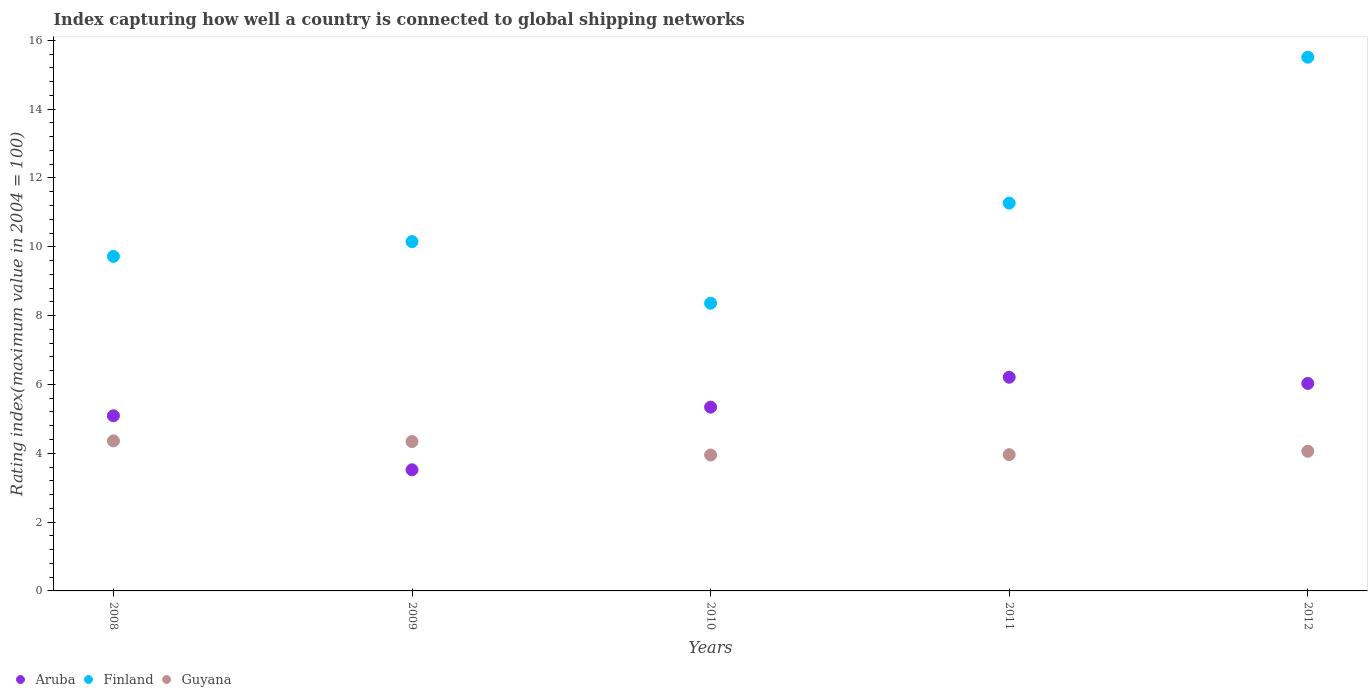How many different coloured dotlines are there?
Make the answer very short. 3. What is the rating index in Aruba in 2008?
Give a very brief answer. 5.09. Across all years, what is the maximum rating index in Aruba?
Ensure brevity in your answer.  6.21. Across all years, what is the minimum rating index in Finland?
Provide a succinct answer. 8.36. In which year was the rating index in Aruba maximum?
Keep it short and to the point. 2011. In which year was the rating index in Finland minimum?
Make the answer very short. 2010. What is the total rating index in Guyana in the graph?
Your answer should be compact. 20.67. What is the difference between the rating index in Aruba in 2009 and that in 2012?
Your answer should be very brief. -2.51. What is the difference between the rating index in Guyana in 2012 and the rating index in Finland in 2009?
Offer a very short reply. -6.09. What is the average rating index in Aruba per year?
Ensure brevity in your answer.  5.24. In the year 2010, what is the difference between the rating index in Guyana and rating index in Finland?
Your answer should be compact. -4.41. In how many years, is the rating index in Guyana greater than 6.8?
Your answer should be very brief. 0. What is the ratio of the rating index in Finland in 2011 to that in 2012?
Give a very brief answer. 0.73. Is the rating index in Guyana in 2011 less than that in 2012?
Provide a succinct answer. Yes. Is the difference between the rating index in Guyana in 2008 and 2011 greater than the difference between the rating index in Finland in 2008 and 2011?
Make the answer very short. Yes. What is the difference between the highest and the second highest rating index in Aruba?
Give a very brief answer. 0.18. What is the difference between the highest and the lowest rating index in Aruba?
Offer a very short reply. 2.69. In how many years, is the rating index in Aruba greater than the average rating index in Aruba taken over all years?
Your answer should be compact. 3. Is the sum of the rating index in Guyana in 2010 and 2011 greater than the maximum rating index in Aruba across all years?
Ensure brevity in your answer.  Yes. Does the rating index in Finland monotonically increase over the years?
Your response must be concise. No. How many dotlines are there?
Offer a very short reply. 3. What is the difference between two consecutive major ticks on the Y-axis?
Your response must be concise. 2. Are the values on the major ticks of Y-axis written in scientific E-notation?
Give a very brief answer. No. Does the graph contain any zero values?
Offer a terse response. No. Where does the legend appear in the graph?
Keep it short and to the point. Bottom left. How many legend labels are there?
Give a very brief answer. 3. What is the title of the graph?
Offer a very short reply. Index capturing how well a country is connected to global shipping networks. Does "Dominican Republic" appear as one of the legend labels in the graph?
Offer a terse response. No. What is the label or title of the Y-axis?
Make the answer very short. Rating index(maximum value in 2004 = 100). What is the Rating index(maximum value in 2004 = 100) in Aruba in 2008?
Keep it short and to the point. 5.09. What is the Rating index(maximum value in 2004 = 100) in Finland in 2008?
Provide a succinct answer. 9.72. What is the Rating index(maximum value in 2004 = 100) in Guyana in 2008?
Make the answer very short. 4.36. What is the Rating index(maximum value in 2004 = 100) in Aruba in 2009?
Ensure brevity in your answer.  3.52. What is the Rating index(maximum value in 2004 = 100) in Finland in 2009?
Offer a terse response. 10.15. What is the Rating index(maximum value in 2004 = 100) in Guyana in 2009?
Provide a succinct answer. 4.34. What is the Rating index(maximum value in 2004 = 100) of Aruba in 2010?
Your response must be concise. 5.34. What is the Rating index(maximum value in 2004 = 100) of Finland in 2010?
Offer a very short reply. 8.36. What is the Rating index(maximum value in 2004 = 100) in Guyana in 2010?
Your answer should be very brief. 3.95. What is the Rating index(maximum value in 2004 = 100) in Aruba in 2011?
Offer a terse response. 6.21. What is the Rating index(maximum value in 2004 = 100) in Finland in 2011?
Offer a terse response. 11.27. What is the Rating index(maximum value in 2004 = 100) of Guyana in 2011?
Offer a terse response. 3.96. What is the Rating index(maximum value in 2004 = 100) of Aruba in 2012?
Your response must be concise. 6.03. What is the Rating index(maximum value in 2004 = 100) in Finland in 2012?
Offer a terse response. 15.51. What is the Rating index(maximum value in 2004 = 100) of Guyana in 2012?
Make the answer very short. 4.06. Across all years, what is the maximum Rating index(maximum value in 2004 = 100) of Aruba?
Your answer should be very brief. 6.21. Across all years, what is the maximum Rating index(maximum value in 2004 = 100) in Finland?
Make the answer very short. 15.51. Across all years, what is the maximum Rating index(maximum value in 2004 = 100) of Guyana?
Your response must be concise. 4.36. Across all years, what is the minimum Rating index(maximum value in 2004 = 100) of Aruba?
Your answer should be very brief. 3.52. Across all years, what is the minimum Rating index(maximum value in 2004 = 100) in Finland?
Your answer should be very brief. 8.36. Across all years, what is the minimum Rating index(maximum value in 2004 = 100) in Guyana?
Ensure brevity in your answer.  3.95. What is the total Rating index(maximum value in 2004 = 100) of Aruba in the graph?
Ensure brevity in your answer.  26.19. What is the total Rating index(maximum value in 2004 = 100) in Finland in the graph?
Your response must be concise. 55.01. What is the total Rating index(maximum value in 2004 = 100) of Guyana in the graph?
Your answer should be compact. 20.67. What is the difference between the Rating index(maximum value in 2004 = 100) of Aruba in 2008 and that in 2009?
Provide a short and direct response. 1.57. What is the difference between the Rating index(maximum value in 2004 = 100) in Finland in 2008 and that in 2009?
Provide a succinct answer. -0.43. What is the difference between the Rating index(maximum value in 2004 = 100) in Guyana in 2008 and that in 2009?
Give a very brief answer. 0.02. What is the difference between the Rating index(maximum value in 2004 = 100) in Finland in 2008 and that in 2010?
Make the answer very short. 1.36. What is the difference between the Rating index(maximum value in 2004 = 100) of Guyana in 2008 and that in 2010?
Your response must be concise. 0.41. What is the difference between the Rating index(maximum value in 2004 = 100) in Aruba in 2008 and that in 2011?
Give a very brief answer. -1.12. What is the difference between the Rating index(maximum value in 2004 = 100) in Finland in 2008 and that in 2011?
Your response must be concise. -1.55. What is the difference between the Rating index(maximum value in 2004 = 100) in Aruba in 2008 and that in 2012?
Your answer should be very brief. -0.94. What is the difference between the Rating index(maximum value in 2004 = 100) of Finland in 2008 and that in 2012?
Your answer should be compact. -5.79. What is the difference between the Rating index(maximum value in 2004 = 100) of Guyana in 2008 and that in 2012?
Your answer should be very brief. 0.3. What is the difference between the Rating index(maximum value in 2004 = 100) of Aruba in 2009 and that in 2010?
Ensure brevity in your answer.  -1.82. What is the difference between the Rating index(maximum value in 2004 = 100) in Finland in 2009 and that in 2010?
Make the answer very short. 1.79. What is the difference between the Rating index(maximum value in 2004 = 100) in Guyana in 2009 and that in 2010?
Keep it short and to the point. 0.39. What is the difference between the Rating index(maximum value in 2004 = 100) in Aruba in 2009 and that in 2011?
Make the answer very short. -2.69. What is the difference between the Rating index(maximum value in 2004 = 100) of Finland in 2009 and that in 2011?
Provide a succinct answer. -1.12. What is the difference between the Rating index(maximum value in 2004 = 100) in Guyana in 2009 and that in 2011?
Your response must be concise. 0.38. What is the difference between the Rating index(maximum value in 2004 = 100) in Aruba in 2009 and that in 2012?
Provide a short and direct response. -2.51. What is the difference between the Rating index(maximum value in 2004 = 100) in Finland in 2009 and that in 2012?
Your answer should be compact. -5.36. What is the difference between the Rating index(maximum value in 2004 = 100) in Guyana in 2009 and that in 2012?
Provide a short and direct response. 0.28. What is the difference between the Rating index(maximum value in 2004 = 100) of Aruba in 2010 and that in 2011?
Ensure brevity in your answer.  -0.87. What is the difference between the Rating index(maximum value in 2004 = 100) in Finland in 2010 and that in 2011?
Keep it short and to the point. -2.91. What is the difference between the Rating index(maximum value in 2004 = 100) of Guyana in 2010 and that in 2011?
Make the answer very short. -0.01. What is the difference between the Rating index(maximum value in 2004 = 100) in Aruba in 2010 and that in 2012?
Offer a terse response. -0.69. What is the difference between the Rating index(maximum value in 2004 = 100) of Finland in 2010 and that in 2012?
Your answer should be compact. -7.15. What is the difference between the Rating index(maximum value in 2004 = 100) in Guyana in 2010 and that in 2012?
Your response must be concise. -0.11. What is the difference between the Rating index(maximum value in 2004 = 100) of Aruba in 2011 and that in 2012?
Offer a terse response. 0.18. What is the difference between the Rating index(maximum value in 2004 = 100) of Finland in 2011 and that in 2012?
Your answer should be very brief. -4.24. What is the difference between the Rating index(maximum value in 2004 = 100) in Aruba in 2008 and the Rating index(maximum value in 2004 = 100) in Finland in 2009?
Provide a succinct answer. -5.06. What is the difference between the Rating index(maximum value in 2004 = 100) of Finland in 2008 and the Rating index(maximum value in 2004 = 100) of Guyana in 2009?
Ensure brevity in your answer.  5.38. What is the difference between the Rating index(maximum value in 2004 = 100) in Aruba in 2008 and the Rating index(maximum value in 2004 = 100) in Finland in 2010?
Offer a very short reply. -3.27. What is the difference between the Rating index(maximum value in 2004 = 100) of Aruba in 2008 and the Rating index(maximum value in 2004 = 100) of Guyana in 2010?
Your response must be concise. 1.14. What is the difference between the Rating index(maximum value in 2004 = 100) in Finland in 2008 and the Rating index(maximum value in 2004 = 100) in Guyana in 2010?
Offer a terse response. 5.77. What is the difference between the Rating index(maximum value in 2004 = 100) of Aruba in 2008 and the Rating index(maximum value in 2004 = 100) of Finland in 2011?
Make the answer very short. -6.18. What is the difference between the Rating index(maximum value in 2004 = 100) in Aruba in 2008 and the Rating index(maximum value in 2004 = 100) in Guyana in 2011?
Make the answer very short. 1.13. What is the difference between the Rating index(maximum value in 2004 = 100) in Finland in 2008 and the Rating index(maximum value in 2004 = 100) in Guyana in 2011?
Offer a very short reply. 5.76. What is the difference between the Rating index(maximum value in 2004 = 100) in Aruba in 2008 and the Rating index(maximum value in 2004 = 100) in Finland in 2012?
Give a very brief answer. -10.42. What is the difference between the Rating index(maximum value in 2004 = 100) in Aruba in 2008 and the Rating index(maximum value in 2004 = 100) in Guyana in 2012?
Your response must be concise. 1.03. What is the difference between the Rating index(maximum value in 2004 = 100) of Finland in 2008 and the Rating index(maximum value in 2004 = 100) of Guyana in 2012?
Your response must be concise. 5.66. What is the difference between the Rating index(maximum value in 2004 = 100) in Aruba in 2009 and the Rating index(maximum value in 2004 = 100) in Finland in 2010?
Offer a terse response. -4.84. What is the difference between the Rating index(maximum value in 2004 = 100) of Aruba in 2009 and the Rating index(maximum value in 2004 = 100) of Guyana in 2010?
Your answer should be compact. -0.43. What is the difference between the Rating index(maximum value in 2004 = 100) in Aruba in 2009 and the Rating index(maximum value in 2004 = 100) in Finland in 2011?
Your answer should be very brief. -7.75. What is the difference between the Rating index(maximum value in 2004 = 100) of Aruba in 2009 and the Rating index(maximum value in 2004 = 100) of Guyana in 2011?
Make the answer very short. -0.44. What is the difference between the Rating index(maximum value in 2004 = 100) in Finland in 2009 and the Rating index(maximum value in 2004 = 100) in Guyana in 2011?
Ensure brevity in your answer.  6.19. What is the difference between the Rating index(maximum value in 2004 = 100) in Aruba in 2009 and the Rating index(maximum value in 2004 = 100) in Finland in 2012?
Your answer should be compact. -11.99. What is the difference between the Rating index(maximum value in 2004 = 100) of Aruba in 2009 and the Rating index(maximum value in 2004 = 100) of Guyana in 2012?
Offer a terse response. -0.54. What is the difference between the Rating index(maximum value in 2004 = 100) of Finland in 2009 and the Rating index(maximum value in 2004 = 100) of Guyana in 2012?
Keep it short and to the point. 6.09. What is the difference between the Rating index(maximum value in 2004 = 100) of Aruba in 2010 and the Rating index(maximum value in 2004 = 100) of Finland in 2011?
Your answer should be compact. -5.93. What is the difference between the Rating index(maximum value in 2004 = 100) of Aruba in 2010 and the Rating index(maximum value in 2004 = 100) of Guyana in 2011?
Provide a succinct answer. 1.38. What is the difference between the Rating index(maximum value in 2004 = 100) of Aruba in 2010 and the Rating index(maximum value in 2004 = 100) of Finland in 2012?
Offer a very short reply. -10.17. What is the difference between the Rating index(maximum value in 2004 = 100) of Aruba in 2010 and the Rating index(maximum value in 2004 = 100) of Guyana in 2012?
Make the answer very short. 1.28. What is the difference between the Rating index(maximum value in 2004 = 100) of Finland in 2010 and the Rating index(maximum value in 2004 = 100) of Guyana in 2012?
Keep it short and to the point. 4.3. What is the difference between the Rating index(maximum value in 2004 = 100) in Aruba in 2011 and the Rating index(maximum value in 2004 = 100) in Guyana in 2012?
Provide a short and direct response. 2.15. What is the difference between the Rating index(maximum value in 2004 = 100) in Finland in 2011 and the Rating index(maximum value in 2004 = 100) in Guyana in 2012?
Keep it short and to the point. 7.21. What is the average Rating index(maximum value in 2004 = 100) of Aruba per year?
Your answer should be very brief. 5.24. What is the average Rating index(maximum value in 2004 = 100) in Finland per year?
Provide a short and direct response. 11. What is the average Rating index(maximum value in 2004 = 100) of Guyana per year?
Provide a succinct answer. 4.13. In the year 2008, what is the difference between the Rating index(maximum value in 2004 = 100) of Aruba and Rating index(maximum value in 2004 = 100) of Finland?
Provide a succinct answer. -4.63. In the year 2008, what is the difference between the Rating index(maximum value in 2004 = 100) of Aruba and Rating index(maximum value in 2004 = 100) of Guyana?
Your response must be concise. 0.73. In the year 2008, what is the difference between the Rating index(maximum value in 2004 = 100) in Finland and Rating index(maximum value in 2004 = 100) in Guyana?
Your response must be concise. 5.36. In the year 2009, what is the difference between the Rating index(maximum value in 2004 = 100) of Aruba and Rating index(maximum value in 2004 = 100) of Finland?
Make the answer very short. -6.63. In the year 2009, what is the difference between the Rating index(maximum value in 2004 = 100) in Aruba and Rating index(maximum value in 2004 = 100) in Guyana?
Provide a short and direct response. -0.82. In the year 2009, what is the difference between the Rating index(maximum value in 2004 = 100) of Finland and Rating index(maximum value in 2004 = 100) of Guyana?
Offer a terse response. 5.81. In the year 2010, what is the difference between the Rating index(maximum value in 2004 = 100) of Aruba and Rating index(maximum value in 2004 = 100) of Finland?
Offer a very short reply. -3.02. In the year 2010, what is the difference between the Rating index(maximum value in 2004 = 100) of Aruba and Rating index(maximum value in 2004 = 100) of Guyana?
Offer a very short reply. 1.39. In the year 2010, what is the difference between the Rating index(maximum value in 2004 = 100) of Finland and Rating index(maximum value in 2004 = 100) of Guyana?
Keep it short and to the point. 4.41. In the year 2011, what is the difference between the Rating index(maximum value in 2004 = 100) of Aruba and Rating index(maximum value in 2004 = 100) of Finland?
Make the answer very short. -5.06. In the year 2011, what is the difference between the Rating index(maximum value in 2004 = 100) in Aruba and Rating index(maximum value in 2004 = 100) in Guyana?
Offer a terse response. 2.25. In the year 2011, what is the difference between the Rating index(maximum value in 2004 = 100) of Finland and Rating index(maximum value in 2004 = 100) of Guyana?
Offer a very short reply. 7.31. In the year 2012, what is the difference between the Rating index(maximum value in 2004 = 100) in Aruba and Rating index(maximum value in 2004 = 100) in Finland?
Keep it short and to the point. -9.48. In the year 2012, what is the difference between the Rating index(maximum value in 2004 = 100) of Aruba and Rating index(maximum value in 2004 = 100) of Guyana?
Give a very brief answer. 1.97. In the year 2012, what is the difference between the Rating index(maximum value in 2004 = 100) in Finland and Rating index(maximum value in 2004 = 100) in Guyana?
Give a very brief answer. 11.45. What is the ratio of the Rating index(maximum value in 2004 = 100) of Aruba in 2008 to that in 2009?
Offer a very short reply. 1.45. What is the ratio of the Rating index(maximum value in 2004 = 100) of Finland in 2008 to that in 2009?
Provide a short and direct response. 0.96. What is the ratio of the Rating index(maximum value in 2004 = 100) of Aruba in 2008 to that in 2010?
Your answer should be very brief. 0.95. What is the ratio of the Rating index(maximum value in 2004 = 100) of Finland in 2008 to that in 2010?
Provide a succinct answer. 1.16. What is the ratio of the Rating index(maximum value in 2004 = 100) in Guyana in 2008 to that in 2010?
Your answer should be very brief. 1.1. What is the ratio of the Rating index(maximum value in 2004 = 100) in Aruba in 2008 to that in 2011?
Provide a short and direct response. 0.82. What is the ratio of the Rating index(maximum value in 2004 = 100) of Finland in 2008 to that in 2011?
Ensure brevity in your answer.  0.86. What is the ratio of the Rating index(maximum value in 2004 = 100) in Guyana in 2008 to that in 2011?
Keep it short and to the point. 1.1. What is the ratio of the Rating index(maximum value in 2004 = 100) in Aruba in 2008 to that in 2012?
Your answer should be very brief. 0.84. What is the ratio of the Rating index(maximum value in 2004 = 100) of Finland in 2008 to that in 2012?
Give a very brief answer. 0.63. What is the ratio of the Rating index(maximum value in 2004 = 100) in Guyana in 2008 to that in 2012?
Your answer should be very brief. 1.07. What is the ratio of the Rating index(maximum value in 2004 = 100) of Aruba in 2009 to that in 2010?
Your response must be concise. 0.66. What is the ratio of the Rating index(maximum value in 2004 = 100) in Finland in 2009 to that in 2010?
Offer a very short reply. 1.21. What is the ratio of the Rating index(maximum value in 2004 = 100) of Guyana in 2009 to that in 2010?
Make the answer very short. 1.1. What is the ratio of the Rating index(maximum value in 2004 = 100) in Aruba in 2009 to that in 2011?
Your answer should be compact. 0.57. What is the ratio of the Rating index(maximum value in 2004 = 100) of Finland in 2009 to that in 2011?
Your answer should be compact. 0.9. What is the ratio of the Rating index(maximum value in 2004 = 100) of Guyana in 2009 to that in 2011?
Offer a very short reply. 1.1. What is the ratio of the Rating index(maximum value in 2004 = 100) of Aruba in 2009 to that in 2012?
Make the answer very short. 0.58. What is the ratio of the Rating index(maximum value in 2004 = 100) of Finland in 2009 to that in 2012?
Make the answer very short. 0.65. What is the ratio of the Rating index(maximum value in 2004 = 100) in Guyana in 2009 to that in 2012?
Ensure brevity in your answer.  1.07. What is the ratio of the Rating index(maximum value in 2004 = 100) in Aruba in 2010 to that in 2011?
Keep it short and to the point. 0.86. What is the ratio of the Rating index(maximum value in 2004 = 100) in Finland in 2010 to that in 2011?
Ensure brevity in your answer.  0.74. What is the ratio of the Rating index(maximum value in 2004 = 100) of Aruba in 2010 to that in 2012?
Keep it short and to the point. 0.89. What is the ratio of the Rating index(maximum value in 2004 = 100) in Finland in 2010 to that in 2012?
Provide a short and direct response. 0.54. What is the ratio of the Rating index(maximum value in 2004 = 100) in Guyana in 2010 to that in 2012?
Keep it short and to the point. 0.97. What is the ratio of the Rating index(maximum value in 2004 = 100) in Aruba in 2011 to that in 2012?
Your answer should be very brief. 1.03. What is the ratio of the Rating index(maximum value in 2004 = 100) of Finland in 2011 to that in 2012?
Offer a terse response. 0.73. What is the ratio of the Rating index(maximum value in 2004 = 100) of Guyana in 2011 to that in 2012?
Your answer should be very brief. 0.98. What is the difference between the highest and the second highest Rating index(maximum value in 2004 = 100) in Aruba?
Offer a very short reply. 0.18. What is the difference between the highest and the second highest Rating index(maximum value in 2004 = 100) of Finland?
Your answer should be compact. 4.24. What is the difference between the highest and the lowest Rating index(maximum value in 2004 = 100) in Aruba?
Offer a very short reply. 2.69. What is the difference between the highest and the lowest Rating index(maximum value in 2004 = 100) in Finland?
Your response must be concise. 7.15. What is the difference between the highest and the lowest Rating index(maximum value in 2004 = 100) in Guyana?
Ensure brevity in your answer.  0.41. 